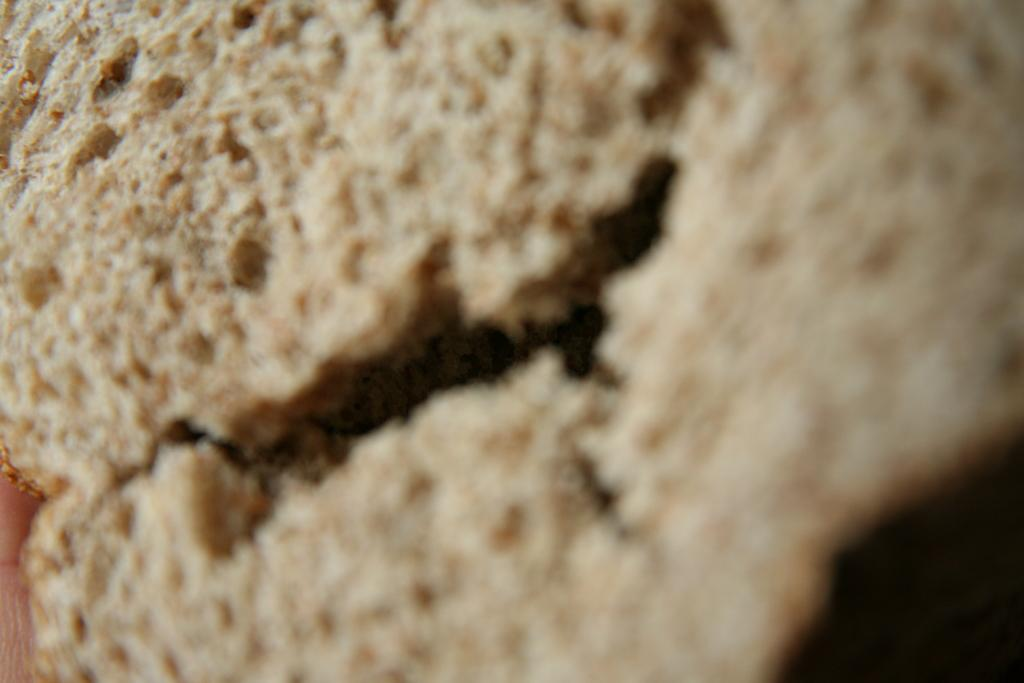What is the focus of the image? The image is zoomed in, with the focus on an object in the center. What is the object in the center of the image? The object appears to be bread. What type of marble is used to create the canvas in the image? There is no marble or canvas present in the image; it features a zoomed-in view of an object that appears to be bread. 